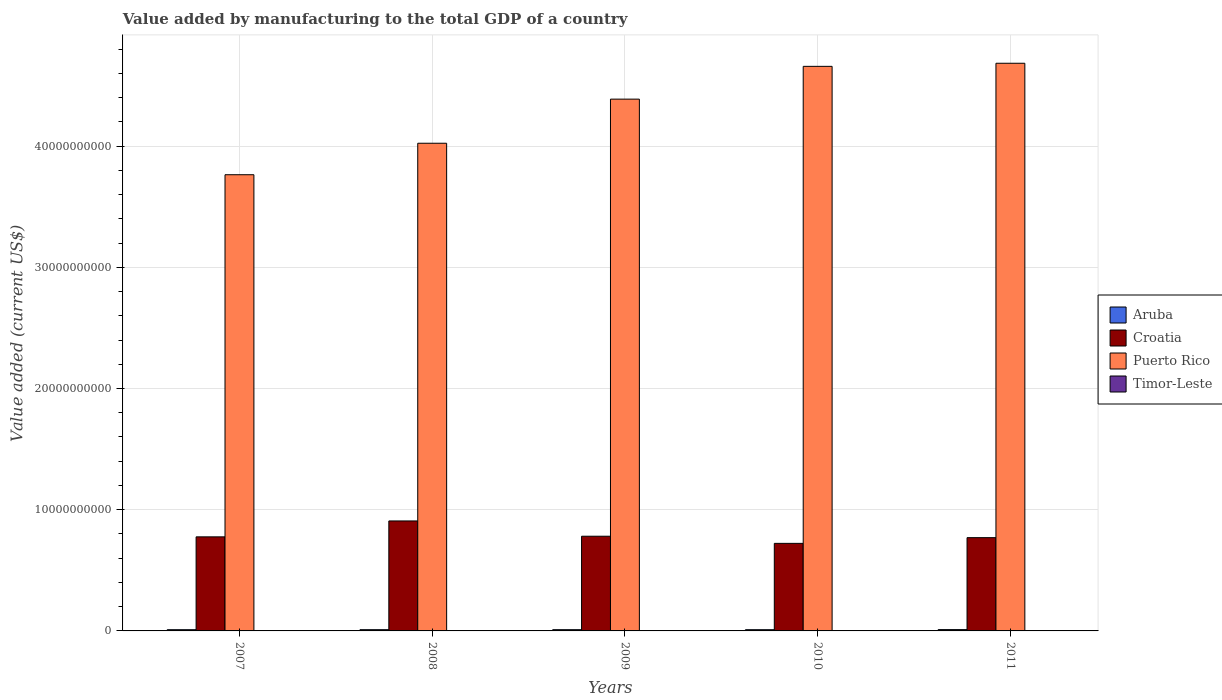Are the number of bars on each tick of the X-axis equal?
Provide a short and direct response. Yes. How many bars are there on the 1st tick from the left?
Make the answer very short. 4. How many bars are there on the 4th tick from the right?
Provide a succinct answer. 4. In how many cases, is the number of bars for a given year not equal to the number of legend labels?
Offer a very short reply. 0. What is the value added by manufacturing to the total GDP in Puerto Rico in 2008?
Provide a short and direct response. 4.02e+1. Across all years, what is the maximum value added by manufacturing to the total GDP in Puerto Rico?
Keep it short and to the point. 4.68e+1. Across all years, what is the minimum value added by manufacturing to the total GDP in Timor-Leste?
Ensure brevity in your answer.  1.00e+07. What is the total value added by manufacturing to the total GDP in Puerto Rico in the graph?
Provide a short and direct response. 2.15e+11. What is the difference between the value added by manufacturing to the total GDP in Croatia in 2007 and that in 2011?
Give a very brief answer. 6.56e+07. What is the difference between the value added by manufacturing to the total GDP in Aruba in 2010 and the value added by manufacturing to the total GDP in Croatia in 2009?
Offer a very short reply. -7.71e+09. What is the average value added by manufacturing to the total GDP in Timor-Leste per year?
Offer a very short reply. 1.12e+07. In the year 2007, what is the difference between the value added by manufacturing to the total GDP in Timor-Leste and value added by manufacturing to the total GDP in Puerto Rico?
Your response must be concise. -3.76e+1. What is the ratio of the value added by manufacturing to the total GDP in Aruba in 2009 to that in 2011?
Your answer should be compact. 0.94. What is the difference between the highest and the lowest value added by manufacturing to the total GDP in Puerto Rico?
Make the answer very short. 9.20e+09. Is the sum of the value added by manufacturing to the total GDP in Croatia in 2007 and 2009 greater than the maximum value added by manufacturing to the total GDP in Timor-Leste across all years?
Make the answer very short. Yes. Is it the case that in every year, the sum of the value added by manufacturing to the total GDP in Timor-Leste and value added by manufacturing to the total GDP in Aruba is greater than the sum of value added by manufacturing to the total GDP in Puerto Rico and value added by manufacturing to the total GDP in Croatia?
Your answer should be very brief. No. What does the 4th bar from the left in 2010 represents?
Your answer should be very brief. Timor-Leste. What does the 4th bar from the right in 2011 represents?
Give a very brief answer. Aruba. How many bars are there?
Ensure brevity in your answer.  20. How many years are there in the graph?
Your response must be concise. 5. Are the values on the major ticks of Y-axis written in scientific E-notation?
Your response must be concise. No. Does the graph contain any zero values?
Your answer should be compact. No. Where does the legend appear in the graph?
Your response must be concise. Center right. How are the legend labels stacked?
Your answer should be very brief. Vertical. What is the title of the graph?
Offer a very short reply. Value added by manufacturing to the total GDP of a country. What is the label or title of the X-axis?
Keep it short and to the point. Years. What is the label or title of the Y-axis?
Keep it short and to the point. Value added (current US$). What is the Value added (current US$) in Aruba in 2007?
Your answer should be compact. 1.01e+08. What is the Value added (current US$) of Croatia in 2007?
Your answer should be very brief. 7.76e+09. What is the Value added (current US$) in Puerto Rico in 2007?
Your answer should be compact. 3.76e+1. What is the Value added (current US$) in Aruba in 2008?
Provide a short and direct response. 1.02e+08. What is the Value added (current US$) in Croatia in 2008?
Provide a short and direct response. 9.07e+09. What is the Value added (current US$) in Puerto Rico in 2008?
Offer a very short reply. 4.02e+1. What is the Value added (current US$) in Aruba in 2009?
Your response must be concise. 1.02e+08. What is the Value added (current US$) in Croatia in 2009?
Ensure brevity in your answer.  7.81e+09. What is the Value added (current US$) of Puerto Rico in 2009?
Keep it short and to the point. 4.39e+1. What is the Value added (current US$) in Timor-Leste in 2009?
Keep it short and to the point. 1.10e+07. What is the Value added (current US$) of Aruba in 2010?
Your answer should be very brief. 1.01e+08. What is the Value added (current US$) in Croatia in 2010?
Provide a short and direct response. 7.22e+09. What is the Value added (current US$) in Puerto Rico in 2010?
Provide a succinct answer. 4.66e+1. What is the Value added (current US$) in Timor-Leste in 2010?
Provide a short and direct response. 1.00e+07. What is the Value added (current US$) of Aruba in 2011?
Make the answer very short. 1.08e+08. What is the Value added (current US$) in Croatia in 2011?
Offer a very short reply. 7.69e+09. What is the Value added (current US$) in Puerto Rico in 2011?
Make the answer very short. 4.68e+1. What is the Value added (current US$) of Timor-Leste in 2011?
Give a very brief answer. 1.10e+07. Across all years, what is the maximum Value added (current US$) of Aruba?
Provide a succinct answer. 1.08e+08. Across all years, what is the maximum Value added (current US$) of Croatia?
Make the answer very short. 9.07e+09. Across all years, what is the maximum Value added (current US$) in Puerto Rico?
Give a very brief answer. 4.68e+1. Across all years, what is the minimum Value added (current US$) in Aruba?
Your answer should be very brief. 1.01e+08. Across all years, what is the minimum Value added (current US$) in Croatia?
Give a very brief answer. 7.22e+09. Across all years, what is the minimum Value added (current US$) in Puerto Rico?
Offer a terse response. 3.76e+1. Across all years, what is the minimum Value added (current US$) of Timor-Leste?
Keep it short and to the point. 1.00e+07. What is the total Value added (current US$) of Aruba in the graph?
Make the answer very short. 5.14e+08. What is the total Value added (current US$) of Croatia in the graph?
Offer a terse response. 3.96e+1. What is the total Value added (current US$) in Puerto Rico in the graph?
Provide a succinct answer. 2.15e+11. What is the total Value added (current US$) in Timor-Leste in the graph?
Your answer should be very brief. 5.60e+07. What is the difference between the Value added (current US$) of Aruba in 2007 and that in 2008?
Your answer should be very brief. -1.11e+06. What is the difference between the Value added (current US$) of Croatia in 2007 and that in 2008?
Give a very brief answer. -1.31e+09. What is the difference between the Value added (current US$) of Puerto Rico in 2007 and that in 2008?
Provide a short and direct response. -2.60e+09. What is the difference between the Value added (current US$) of Aruba in 2007 and that in 2009?
Your response must be concise. -1.44e+06. What is the difference between the Value added (current US$) of Croatia in 2007 and that in 2009?
Ensure brevity in your answer.  -5.19e+07. What is the difference between the Value added (current US$) in Puerto Rico in 2007 and that in 2009?
Your response must be concise. -6.24e+09. What is the difference between the Value added (current US$) in Aruba in 2007 and that in 2010?
Offer a terse response. -4.08e+05. What is the difference between the Value added (current US$) in Croatia in 2007 and that in 2010?
Provide a succinct answer. 5.37e+08. What is the difference between the Value added (current US$) in Puerto Rico in 2007 and that in 2010?
Offer a terse response. -8.94e+09. What is the difference between the Value added (current US$) in Aruba in 2007 and that in 2011?
Offer a very short reply. -7.46e+06. What is the difference between the Value added (current US$) of Croatia in 2007 and that in 2011?
Ensure brevity in your answer.  6.56e+07. What is the difference between the Value added (current US$) in Puerto Rico in 2007 and that in 2011?
Ensure brevity in your answer.  -9.20e+09. What is the difference between the Value added (current US$) of Aruba in 2008 and that in 2009?
Your response must be concise. -3.30e+05. What is the difference between the Value added (current US$) in Croatia in 2008 and that in 2009?
Offer a very short reply. 1.26e+09. What is the difference between the Value added (current US$) in Puerto Rico in 2008 and that in 2009?
Provide a short and direct response. -3.64e+09. What is the difference between the Value added (current US$) in Aruba in 2008 and that in 2010?
Ensure brevity in your answer.  7.04e+05. What is the difference between the Value added (current US$) of Croatia in 2008 and that in 2010?
Offer a terse response. 1.85e+09. What is the difference between the Value added (current US$) of Puerto Rico in 2008 and that in 2010?
Make the answer very short. -6.34e+09. What is the difference between the Value added (current US$) in Aruba in 2008 and that in 2011?
Provide a short and direct response. -6.35e+06. What is the difference between the Value added (current US$) in Croatia in 2008 and that in 2011?
Provide a succinct answer. 1.38e+09. What is the difference between the Value added (current US$) of Puerto Rico in 2008 and that in 2011?
Give a very brief answer. -6.60e+09. What is the difference between the Value added (current US$) in Aruba in 2009 and that in 2010?
Offer a terse response. 1.03e+06. What is the difference between the Value added (current US$) in Croatia in 2009 and that in 2010?
Offer a terse response. 5.88e+08. What is the difference between the Value added (current US$) of Puerto Rico in 2009 and that in 2010?
Ensure brevity in your answer.  -2.71e+09. What is the difference between the Value added (current US$) of Timor-Leste in 2009 and that in 2010?
Your answer should be very brief. 1.00e+06. What is the difference between the Value added (current US$) of Aruba in 2009 and that in 2011?
Ensure brevity in your answer.  -6.02e+06. What is the difference between the Value added (current US$) in Croatia in 2009 and that in 2011?
Offer a terse response. 1.18e+08. What is the difference between the Value added (current US$) in Puerto Rico in 2009 and that in 2011?
Offer a terse response. -2.96e+09. What is the difference between the Value added (current US$) of Aruba in 2010 and that in 2011?
Provide a short and direct response. -7.06e+06. What is the difference between the Value added (current US$) of Croatia in 2010 and that in 2011?
Your response must be concise. -4.71e+08. What is the difference between the Value added (current US$) in Puerto Rico in 2010 and that in 2011?
Provide a succinct answer. -2.55e+08. What is the difference between the Value added (current US$) in Aruba in 2007 and the Value added (current US$) in Croatia in 2008?
Provide a succinct answer. -8.97e+09. What is the difference between the Value added (current US$) of Aruba in 2007 and the Value added (current US$) of Puerto Rico in 2008?
Provide a succinct answer. -4.01e+1. What is the difference between the Value added (current US$) of Aruba in 2007 and the Value added (current US$) of Timor-Leste in 2008?
Provide a succinct answer. 8.88e+07. What is the difference between the Value added (current US$) of Croatia in 2007 and the Value added (current US$) of Puerto Rico in 2008?
Your response must be concise. -3.25e+1. What is the difference between the Value added (current US$) of Croatia in 2007 and the Value added (current US$) of Timor-Leste in 2008?
Offer a very short reply. 7.75e+09. What is the difference between the Value added (current US$) of Puerto Rico in 2007 and the Value added (current US$) of Timor-Leste in 2008?
Keep it short and to the point. 3.76e+1. What is the difference between the Value added (current US$) in Aruba in 2007 and the Value added (current US$) in Croatia in 2009?
Offer a very short reply. -7.71e+09. What is the difference between the Value added (current US$) in Aruba in 2007 and the Value added (current US$) in Puerto Rico in 2009?
Provide a succinct answer. -4.38e+1. What is the difference between the Value added (current US$) in Aruba in 2007 and the Value added (current US$) in Timor-Leste in 2009?
Give a very brief answer. 8.98e+07. What is the difference between the Value added (current US$) in Croatia in 2007 and the Value added (current US$) in Puerto Rico in 2009?
Provide a short and direct response. -3.61e+1. What is the difference between the Value added (current US$) in Croatia in 2007 and the Value added (current US$) in Timor-Leste in 2009?
Offer a terse response. 7.75e+09. What is the difference between the Value added (current US$) in Puerto Rico in 2007 and the Value added (current US$) in Timor-Leste in 2009?
Your answer should be very brief. 3.76e+1. What is the difference between the Value added (current US$) of Aruba in 2007 and the Value added (current US$) of Croatia in 2010?
Offer a very short reply. -7.12e+09. What is the difference between the Value added (current US$) in Aruba in 2007 and the Value added (current US$) in Puerto Rico in 2010?
Make the answer very short. -4.65e+1. What is the difference between the Value added (current US$) in Aruba in 2007 and the Value added (current US$) in Timor-Leste in 2010?
Your response must be concise. 9.08e+07. What is the difference between the Value added (current US$) of Croatia in 2007 and the Value added (current US$) of Puerto Rico in 2010?
Give a very brief answer. -3.88e+1. What is the difference between the Value added (current US$) in Croatia in 2007 and the Value added (current US$) in Timor-Leste in 2010?
Make the answer very short. 7.75e+09. What is the difference between the Value added (current US$) of Puerto Rico in 2007 and the Value added (current US$) of Timor-Leste in 2010?
Offer a terse response. 3.76e+1. What is the difference between the Value added (current US$) of Aruba in 2007 and the Value added (current US$) of Croatia in 2011?
Make the answer very short. -7.59e+09. What is the difference between the Value added (current US$) in Aruba in 2007 and the Value added (current US$) in Puerto Rico in 2011?
Make the answer very short. -4.67e+1. What is the difference between the Value added (current US$) in Aruba in 2007 and the Value added (current US$) in Timor-Leste in 2011?
Ensure brevity in your answer.  8.98e+07. What is the difference between the Value added (current US$) of Croatia in 2007 and the Value added (current US$) of Puerto Rico in 2011?
Your response must be concise. -3.91e+1. What is the difference between the Value added (current US$) in Croatia in 2007 and the Value added (current US$) in Timor-Leste in 2011?
Provide a short and direct response. 7.75e+09. What is the difference between the Value added (current US$) in Puerto Rico in 2007 and the Value added (current US$) in Timor-Leste in 2011?
Offer a very short reply. 3.76e+1. What is the difference between the Value added (current US$) in Aruba in 2008 and the Value added (current US$) in Croatia in 2009?
Offer a very short reply. -7.71e+09. What is the difference between the Value added (current US$) in Aruba in 2008 and the Value added (current US$) in Puerto Rico in 2009?
Keep it short and to the point. -4.38e+1. What is the difference between the Value added (current US$) of Aruba in 2008 and the Value added (current US$) of Timor-Leste in 2009?
Offer a terse response. 9.09e+07. What is the difference between the Value added (current US$) of Croatia in 2008 and the Value added (current US$) of Puerto Rico in 2009?
Your answer should be compact. -3.48e+1. What is the difference between the Value added (current US$) in Croatia in 2008 and the Value added (current US$) in Timor-Leste in 2009?
Offer a terse response. 9.06e+09. What is the difference between the Value added (current US$) of Puerto Rico in 2008 and the Value added (current US$) of Timor-Leste in 2009?
Make the answer very short. 4.02e+1. What is the difference between the Value added (current US$) of Aruba in 2008 and the Value added (current US$) of Croatia in 2010?
Provide a succinct answer. -7.12e+09. What is the difference between the Value added (current US$) of Aruba in 2008 and the Value added (current US$) of Puerto Rico in 2010?
Provide a short and direct response. -4.65e+1. What is the difference between the Value added (current US$) of Aruba in 2008 and the Value added (current US$) of Timor-Leste in 2010?
Your answer should be very brief. 9.19e+07. What is the difference between the Value added (current US$) in Croatia in 2008 and the Value added (current US$) in Puerto Rico in 2010?
Make the answer very short. -3.75e+1. What is the difference between the Value added (current US$) in Croatia in 2008 and the Value added (current US$) in Timor-Leste in 2010?
Make the answer very short. 9.06e+09. What is the difference between the Value added (current US$) in Puerto Rico in 2008 and the Value added (current US$) in Timor-Leste in 2010?
Provide a short and direct response. 4.02e+1. What is the difference between the Value added (current US$) of Aruba in 2008 and the Value added (current US$) of Croatia in 2011?
Give a very brief answer. -7.59e+09. What is the difference between the Value added (current US$) of Aruba in 2008 and the Value added (current US$) of Puerto Rico in 2011?
Your response must be concise. -4.67e+1. What is the difference between the Value added (current US$) of Aruba in 2008 and the Value added (current US$) of Timor-Leste in 2011?
Give a very brief answer. 9.09e+07. What is the difference between the Value added (current US$) of Croatia in 2008 and the Value added (current US$) of Puerto Rico in 2011?
Your response must be concise. -3.78e+1. What is the difference between the Value added (current US$) of Croatia in 2008 and the Value added (current US$) of Timor-Leste in 2011?
Your answer should be very brief. 9.06e+09. What is the difference between the Value added (current US$) in Puerto Rico in 2008 and the Value added (current US$) in Timor-Leste in 2011?
Provide a short and direct response. 4.02e+1. What is the difference between the Value added (current US$) of Aruba in 2009 and the Value added (current US$) of Croatia in 2010?
Your answer should be very brief. -7.12e+09. What is the difference between the Value added (current US$) of Aruba in 2009 and the Value added (current US$) of Puerto Rico in 2010?
Keep it short and to the point. -4.65e+1. What is the difference between the Value added (current US$) in Aruba in 2009 and the Value added (current US$) in Timor-Leste in 2010?
Make the answer very short. 9.22e+07. What is the difference between the Value added (current US$) in Croatia in 2009 and the Value added (current US$) in Puerto Rico in 2010?
Your answer should be compact. -3.88e+1. What is the difference between the Value added (current US$) in Croatia in 2009 and the Value added (current US$) in Timor-Leste in 2010?
Provide a succinct answer. 7.80e+09. What is the difference between the Value added (current US$) in Puerto Rico in 2009 and the Value added (current US$) in Timor-Leste in 2010?
Offer a very short reply. 4.39e+1. What is the difference between the Value added (current US$) in Aruba in 2009 and the Value added (current US$) in Croatia in 2011?
Keep it short and to the point. -7.59e+09. What is the difference between the Value added (current US$) in Aruba in 2009 and the Value added (current US$) in Puerto Rico in 2011?
Make the answer very short. -4.67e+1. What is the difference between the Value added (current US$) in Aruba in 2009 and the Value added (current US$) in Timor-Leste in 2011?
Provide a succinct answer. 9.12e+07. What is the difference between the Value added (current US$) in Croatia in 2009 and the Value added (current US$) in Puerto Rico in 2011?
Make the answer very short. -3.90e+1. What is the difference between the Value added (current US$) of Croatia in 2009 and the Value added (current US$) of Timor-Leste in 2011?
Provide a succinct answer. 7.80e+09. What is the difference between the Value added (current US$) in Puerto Rico in 2009 and the Value added (current US$) in Timor-Leste in 2011?
Provide a succinct answer. 4.39e+1. What is the difference between the Value added (current US$) of Aruba in 2010 and the Value added (current US$) of Croatia in 2011?
Keep it short and to the point. -7.59e+09. What is the difference between the Value added (current US$) of Aruba in 2010 and the Value added (current US$) of Puerto Rico in 2011?
Your answer should be very brief. -4.67e+1. What is the difference between the Value added (current US$) in Aruba in 2010 and the Value added (current US$) in Timor-Leste in 2011?
Keep it short and to the point. 9.02e+07. What is the difference between the Value added (current US$) in Croatia in 2010 and the Value added (current US$) in Puerto Rico in 2011?
Your response must be concise. -3.96e+1. What is the difference between the Value added (current US$) in Croatia in 2010 and the Value added (current US$) in Timor-Leste in 2011?
Provide a succinct answer. 7.21e+09. What is the difference between the Value added (current US$) of Puerto Rico in 2010 and the Value added (current US$) of Timor-Leste in 2011?
Your response must be concise. 4.66e+1. What is the average Value added (current US$) of Aruba per year?
Give a very brief answer. 1.03e+08. What is the average Value added (current US$) in Croatia per year?
Offer a very short reply. 7.91e+09. What is the average Value added (current US$) of Puerto Rico per year?
Your answer should be compact. 4.30e+1. What is the average Value added (current US$) in Timor-Leste per year?
Your answer should be compact. 1.12e+07. In the year 2007, what is the difference between the Value added (current US$) of Aruba and Value added (current US$) of Croatia?
Your answer should be compact. -7.66e+09. In the year 2007, what is the difference between the Value added (current US$) of Aruba and Value added (current US$) of Puerto Rico?
Give a very brief answer. -3.75e+1. In the year 2007, what is the difference between the Value added (current US$) in Aruba and Value added (current US$) in Timor-Leste?
Keep it short and to the point. 8.88e+07. In the year 2007, what is the difference between the Value added (current US$) of Croatia and Value added (current US$) of Puerto Rico?
Make the answer very short. -2.99e+1. In the year 2007, what is the difference between the Value added (current US$) of Croatia and Value added (current US$) of Timor-Leste?
Your response must be concise. 7.75e+09. In the year 2007, what is the difference between the Value added (current US$) in Puerto Rico and Value added (current US$) in Timor-Leste?
Keep it short and to the point. 3.76e+1. In the year 2008, what is the difference between the Value added (current US$) in Aruba and Value added (current US$) in Croatia?
Keep it short and to the point. -8.97e+09. In the year 2008, what is the difference between the Value added (current US$) of Aruba and Value added (current US$) of Puerto Rico?
Offer a very short reply. -4.01e+1. In the year 2008, what is the difference between the Value added (current US$) of Aruba and Value added (current US$) of Timor-Leste?
Offer a very short reply. 8.99e+07. In the year 2008, what is the difference between the Value added (current US$) in Croatia and Value added (current US$) in Puerto Rico?
Your response must be concise. -3.12e+1. In the year 2008, what is the difference between the Value added (current US$) of Croatia and Value added (current US$) of Timor-Leste?
Ensure brevity in your answer.  9.06e+09. In the year 2008, what is the difference between the Value added (current US$) of Puerto Rico and Value added (current US$) of Timor-Leste?
Give a very brief answer. 4.02e+1. In the year 2009, what is the difference between the Value added (current US$) of Aruba and Value added (current US$) of Croatia?
Your answer should be very brief. -7.71e+09. In the year 2009, what is the difference between the Value added (current US$) of Aruba and Value added (current US$) of Puerto Rico?
Give a very brief answer. -4.38e+1. In the year 2009, what is the difference between the Value added (current US$) of Aruba and Value added (current US$) of Timor-Leste?
Provide a short and direct response. 9.12e+07. In the year 2009, what is the difference between the Value added (current US$) of Croatia and Value added (current US$) of Puerto Rico?
Offer a terse response. -3.61e+1. In the year 2009, what is the difference between the Value added (current US$) in Croatia and Value added (current US$) in Timor-Leste?
Offer a very short reply. 7.80e+09. In the year 2009, what is the difference between the Value added (current US$) of Puerto Rico and Value added (current US$) of Timor-Leste?
Provide a succinct answer. 4.39e+1. In the year 2010, what is the difference between the Value added (current US$) of Aruba and Value added (current US$) of Croatia?
Your answer should be very brief. -7.12e+09. In the year 2010, what is the difference between the Value added (current US$) in Aruba and Value added (current US$) in Puerto Rico?
Provide a short and direct response. -4.65e+1. In the year 2010, what is the difference between the Value added (current US$) in Aruba and Value added (current US$) in Timor-Leste?
Keep it short and to the point. 9.12e+07. In the year 2010, what is the difference between the Value added (current US$) of Croatia and Value added (current US$) of Puerto Rico?
Offer a terse response. -3.94e+1. In the year 2010, what is the difference between the Value added (current US$) in Croatia and Value added (current US$) in Timor-Leste?
Provide a succinct answer. 7.21e+09. In the year 2010, what is the difference between the Value added (current US$) in Puerto Rico and Value added (current US$) in Timor-Leste?
Your response must be concise. 4.66e+1. In the year 2011, what is the difference between the Value added (current US$) of Aruba and Value added (current US$) of Croatia?
Ensure brevity in your answer.  -7.59e+09. In the year 2011, what is the difference between the Value added (current US$) of Aruba and Value added (current US$) of Puerto Rico?
Provide a succinct answer. -4.67e+1. In the year 2011, what is the difference between the Value added (current US$) of Aruba and Value added (current US$) of Timor-Leste?
Your answer should be very brief. 9.73e+07. In the year 2011, what is the difference between the Value added (current US$) in Croatia and Value added (current US$) in Puerto Rico?
Ensure brevity in your answer.  -3.91e+1. In the year 2011, what is the difference between the Value added (current US$) in Croatia and Value added (current US$) in Timor-Leste?
Give a very brief answer. 7.68e+09. In the year 2011, what is the difference between the Value added (current US$) of Puerto Rico and Value added (current US$) of Timor-Leste?
Keep it short and to the point. 4.68e+1. What is the ratio of the Value added (current US$) of Croatia in 2007 to that in 2008?
Offer a terse response. 0.86. What is the ratio of the Value added (current US$) in Puerto Rico in 2007 to that in 2008?
Keep it short and to the point. 0.94. What is the ratio of the Value added (current US$) of Aruba in 2007 to that in 2009?
Make the answer very short. 0.99. What is the ratio of the Value added (current US$) of Puerto Rico in 2007 to that in 2009?
Make the answer very short. 0.86. What is the ratio of the Value added (current US$) of Timor-Leste in 2007 to that in 2009?
Your response must be concise. 1.09. What is the ratio of the Value added (current US$) of Aruba in 2007 to that in 2010?
Offer a terse response. 1. What is the ratio of the Value added (current US$) in Croatia in 2007 to that in 2010?
Your answer should be very brief. 1.07. What is the ratio of the Value added (current US$) in Puerto Rico in 2007 to that in 2010?
Your answer should be very brief. 0.81. What is the ratio of the Value added (current US$) of Timor-Leste in 2007 to that in 2010?
Keep it short and to the point. 1.2. What is the ratio of the Value added (current US$) of Aruba in 2007 to that in 2011?
Make the answer very short. 0.93. What is the ratio of the Value added (current US$) in Croatia in 2007 to that in 2011?
Give a very brief answer. 1.01. What is the ratio of the Value added (current US$) of Puerto Rico in 2007 to that in 2011?
Your answer should be very brief. 0.8. What is the ratio of the Value added (current US$) of Aruba in 2008 to that in 2009?
Ensure brevity in your answer.  1. What is the ratio of the Value added (current US$) in Croatia in 2008 to that in 2009?
Ensure brevity in your answer.  1.16. What is the ratio of the Value added (current US$) in Puerto Rico in 2008 to that in 2009?
Offer a terse response. 0.92. What is the ratio of the Value added (current US$) in Timor-Leste in 2008 to that in 2009?
Your answer should be very brief. 1.09. What is the ratio of the Value added (current US$) in Croatia in 2008 to that in 2010?
Offer a terse response. 1.26. What is the ratio of the Value added (current US$) of Puerto Rico in 2008 to that in 2010?
Offer a terse response. 0.86. What is the ratio of the Value added (current US$) of Timor-Leste in 2008 to that in 2010?
Keep it short and to the point. 1.2. What is the ratio of the Value added (current US$) in Aruba in 2008 to that in 2011?
Keep it short and to the point. 0.94. What is the ratio of the Value added (current US$) in Croatia in 2008 to that in 2011?
Offer a very short reply. 1.18. What is the ratio of the Value added (current US$) of Puerto Rico in 2008 to that in 2011?
Offer a terse response. 0.86. What is the ratio of the Value added (current US$) in Aruba in 2009 to that in 2010?
Ensure brevity in your answer.  1.01. What is the ratio of the Value added (current US$) in Croatia in 2009 to that in 2010?
Your answer should be compact. 1.08. What is the ratio of the Value added (current US$) in Puerto Rico in 2009 to that in 2010?
Offer a terse response. 0.94. What is the ratio of the Value added (current US$) of Timor-Leste in 2009 to that in 2010?
Your answer should be very brief. 1.1. What is the ratio of the Value added (current US$) of Aruba in 2009 to that in 2011?
Keep it short and to the point. 0.94. What is the ratio of the Value added (current US$) in Croatia in 2009 to that in 2011?
Offer a terse response. 1.02. What is the ratio of the Value added (current US$) of Puerto Rico in 2009 to that in 2011?
Ensure brevity in your answer.  0.94. What is the ratio of the Value added (current US$) of Aruba in 2010 to that in 2011?
Your answer should be compact. 0.93. What is the ratio of the Value added (current US$) of Croatia in 2010 to that in 2011?
Make the answer very short. 0.94. What is the ratio of the Value added (current US$) of Puerto Rico in 2010 to that in 2011?
Ensure brevity in your answer.  0.99. What is the difference between the highest and the second highest Value added (current US$) of Aruba?
Your answer should be compact. 6.02e+06. What is the difference between the highest and the second highest Value added (current US$) in Croatia?
Make the answer very short. 1.26e+09. What is the difference between the highest and the second highest Value added (current US$) in Puerto Rico?
Keep it short and to the point. 2.55e+08. What is the difference between the highest and the lowest Value added (current US$) in Aruba?
Make the answer very short. 7.46e+06. What is the difference between the highest and the lowest Value added (current US$) in Croatia?
Your answer should be compact. 1.85e+09. What is the difference between the highest and the lowest Value added (current US$) in Puerto Rico?
Ensure brevity in your answer.  9.20e+09. What is the difference between the highest and the lowest Value added (current US$) in Timor-Leste?
Your answer should be compact. 2.00e+06. 